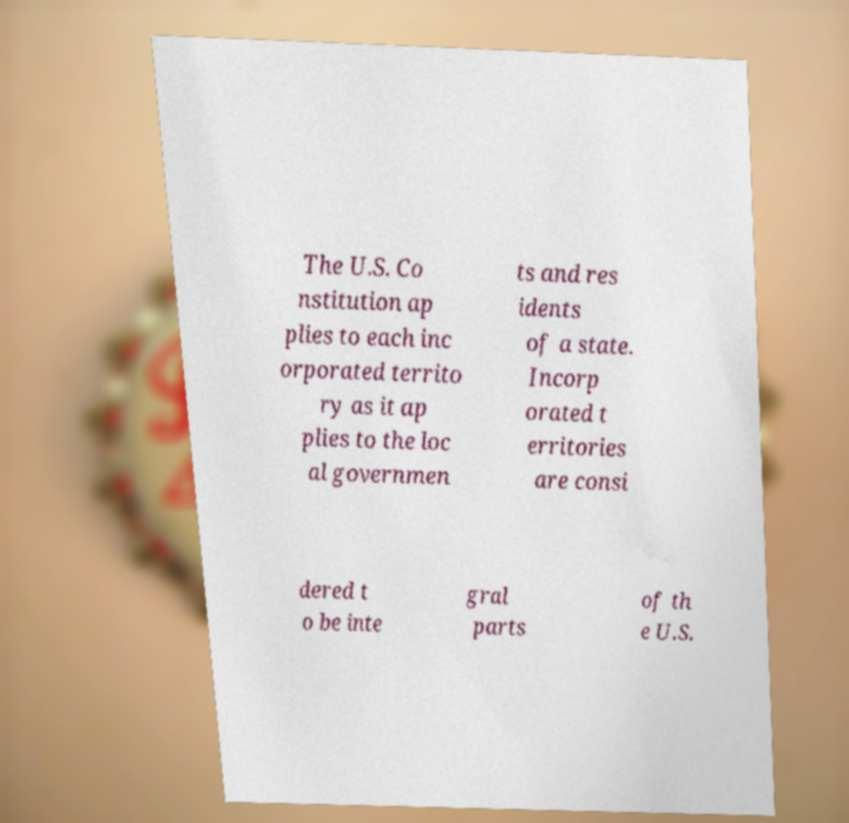Can you read and provide the text displayed in the image?This photo seems to have some interesting text. Can you extract and type it out for me? The U.S. Co nstitution ap plies to each inc orporated territo ry as it ap plies to the loc al governmen ts and res idents of a state. Incorp orated t erritories are consi dered t o be inte gral parts of th e U.S. 